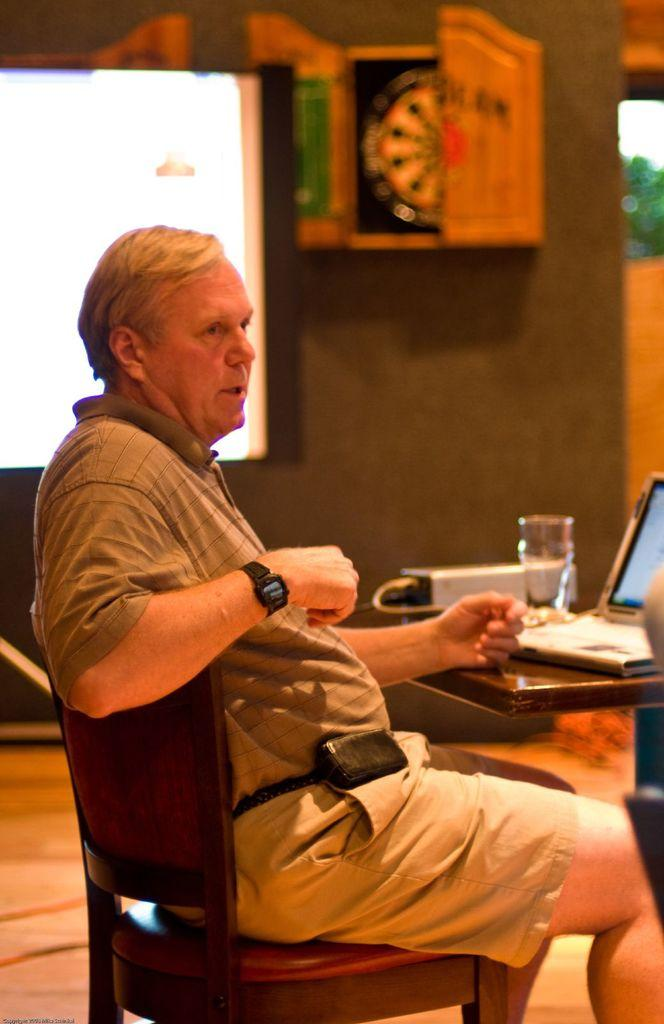What is the man in the image doing? The man is sitting on a chair in the image. What can be seen on the table in front of the man? There is a laptop and a glass on the table. What else is on the table? There is a device on the table. What is visible in the background of the image? There is a screen and a wall in the background of the image, along with other objects. What type of quince is being used as a paperweight on the table? There is no quince present on the table in the image. How many seeds are visible in the glass on the table? There are no seeds visible in the glass on the table in the image. 